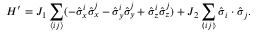<formula> <loc_0><loc_0><loc_500><loc_500>H ^ { \prime } = J _ { 1 } \sum _ { \langle i j \rangle } ( - \hat { \sigma } _ { x } ^ { i } \hat { \sigma } _ { x } ^ { j } - \hat { \sigma } _ { y } ^ { i } \hat { \sigma } _ { y } ^ { j } + \hat { \sigma } _ { z } ^ { i } \hat { \sigma } _ { z } ^ { j } ) + J _ { 2 } \sum _ { \ll a n g l e i j \ r r a n g l e } \hat { \sigma } _ { i } \cdot \hat { \sigma } _ { j } .</formula> 